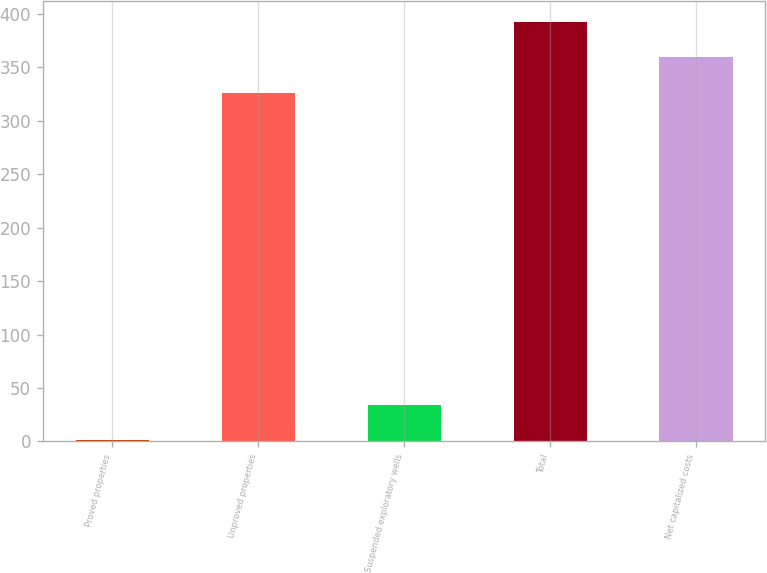Convert chart to OTSL. <chart><loc_0><loc_0><loc_500><loc_500><bar_chart><fcel>Proved properties<fcel>Unproved properties<fcel>Suspended exploratory wells<fcel>Total<fcel>Net capitalized costs<nl><fcel>1<fcel>326<fcel>34.4<fcel>392.8<fcel>359.4<nl></chart> 